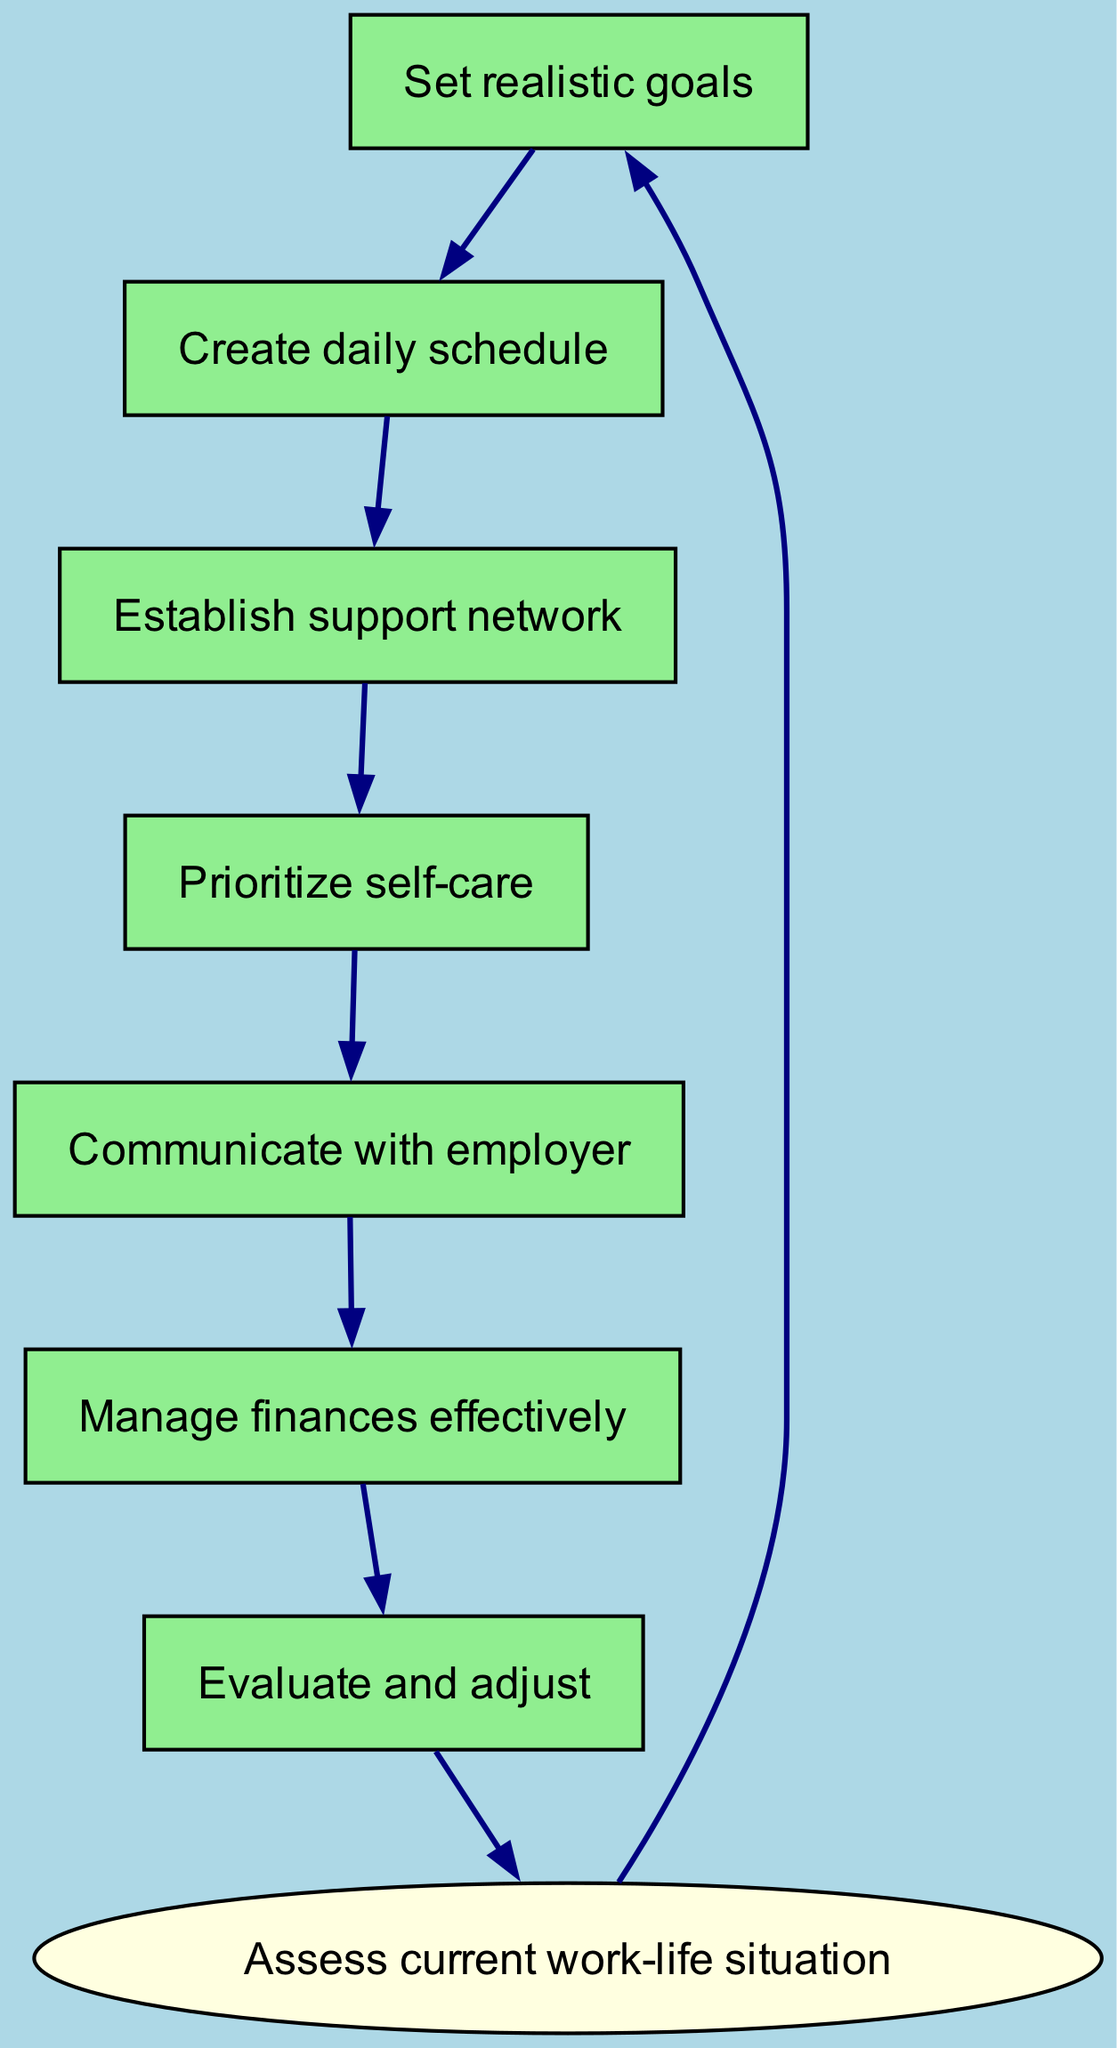What is the start node in the diagram? The start node is the initial step of the workflow, which is indicated in the diagram and labeled as "Assess current work-life situation."
Answer: Assess current work-life situation How many nodes are in the diagram? To find the number of nodes, count all the unique points in the diagram including the start node and all subsequent nodes listed. There are 7 nodes total.
Answer: 7 What are the last two activities in the flow? The last two activities can be identified by following the edges from the last node leading back to the start node. They are "Manage finances effectively" and "Evaluate and adjust."
Answer: Manage finances effectively, Evaluate and adjust Which node comes after "Prioritize self-care"? The diagram shows a clear flow of activities, and "Communicate with employer" follows "Prioritize self-care" directly according to the established edges.
Answer: Communicate with employer What is the second node in the workflow? The nodes are arranged in the order of edges drawn from the start node. The second node, following "Assess current work-life situation," is "Set realistic goals."
Answer: Set realistic goals What is the relationship between "Establish support network" and "Create daily schedule"? "Establish support network" is directly dependent upon "Create daily schedule," indicating that a schedule is created first before establishing the support network. The edge leads from "Create daily schedule" to "Establish support network."
Answer: Establish support network depends on Create daily schedule What is the last node in the sequence? To determine the last node, look at the flow chart progression, where "Evaluate and adjust" is the final node that leads back to the start, completing the cycle.
Answer: Evaluate and adjust How many edges are depicted in the diagram? To find the number of edges, count the directed lines connecting the nodes, which showcase the workflow transitions. There are 7 edges total, indicating movement through the nodes.
Answer: 7 